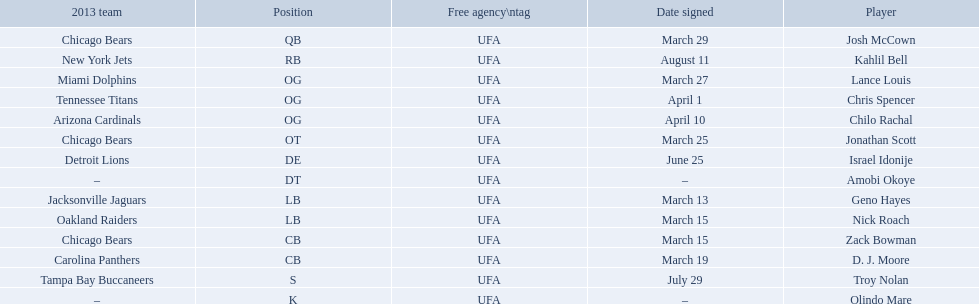Who are all of the players? Josh McCown, Kahlil Bell, Lance Louis, Chris Spencer, Chilo Rachal, Jonathan Scott, Israel Idonije, Amobi Okoye, Geno Hayes, Nick Roach, Zack Bowman, D. J. Moore, Troy Nolan, Olindo Mare. When were they signed? March 29, August 11, March 27, April 1, April 10, March 25, June 25, –, March 13, March 15, March 15, March 19, July 29, –. Along with nick roach, who else was signed on march 15? Zack Bowman. 